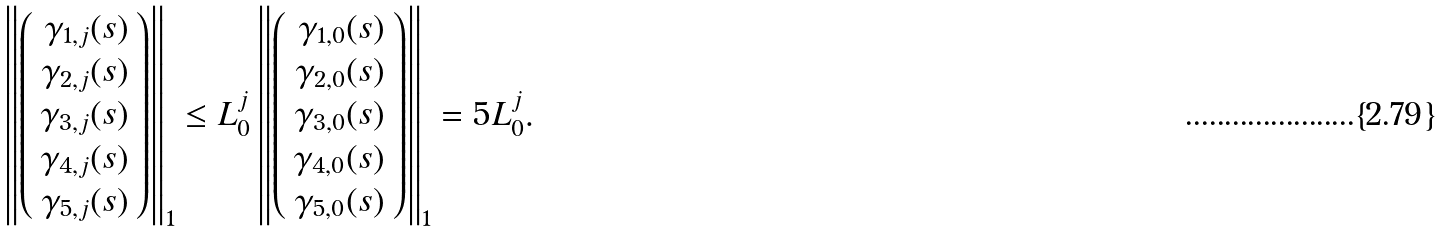<formula> <loc_0><loc_0><loc_500><loc_500>\left \| \left ( \begin{array} { r } \gamma _ { 1 , j } ( s ) \\ \gamma _ { 2 , j } ( s ) \\ \gamma _ { 3 , j } ( s ) \\ \gamma _ { 4 , j } ( s ) \\ \gamma _ { 5 , j } ( s ) \end{array} \right ) \right \| _ { 1 } \leq L _ { 0 } ^ { j } \left \| \left ( \begin{array} { r } \gamma _ { 1 , 0 } ( s ) \\ \gamma _ { 2 , 0 } ( s ) \\ \gamma _ { 3 , 0 } ( s ) \\ \gamma _ { 4 , 0 } ( s ) \\ \gamma _ { 5 , 0 } ( s ) \end{array} \right ) \right \| _ { 1 } = 5 L _ { 0 } ^ { j } .</formula> 